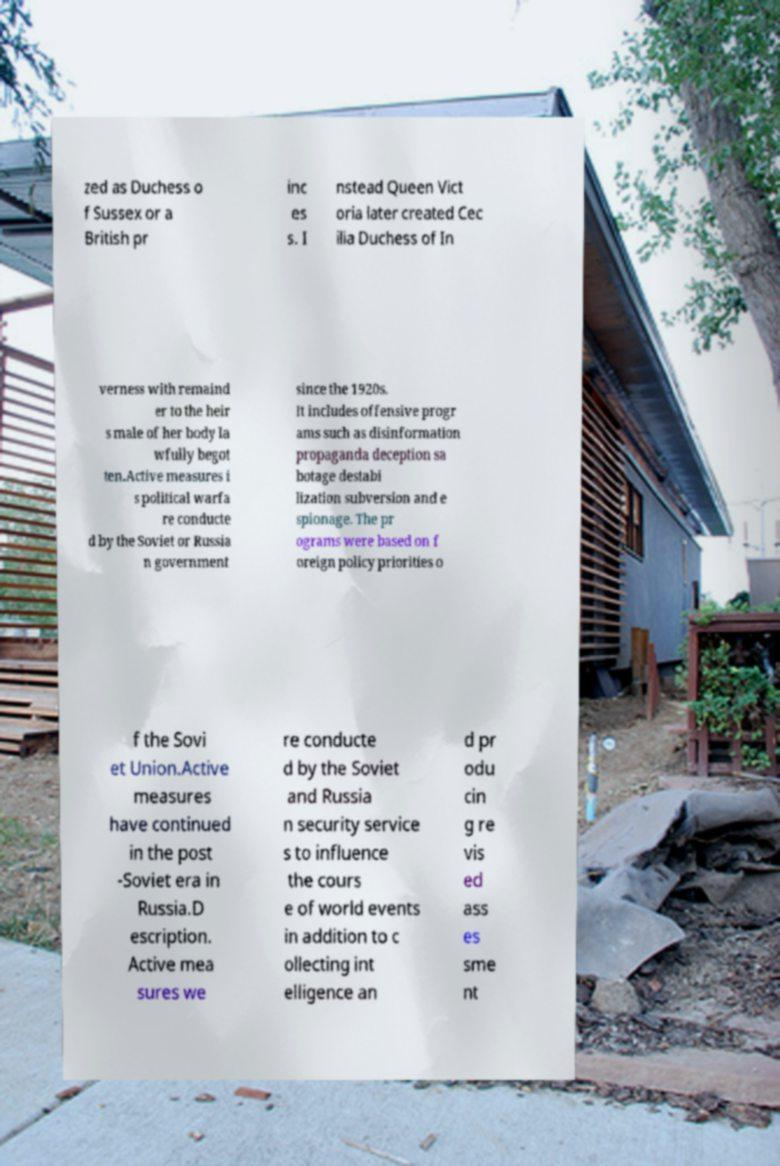Can you read and provide the text displayed in the image?This photo seems to have some interesting text. Can you extract and type it out for me? zed as Duchess o f Sussex or a British pr inc es s. I nstead Queen Vict oria later created Cec ilia Duchess of In verness with remaind er to the heir s male of her body la wfully begot ten.Active measures i s political warfa re conducte d by the Soviet or Russia n government since the 1920s. It includes offensive progr ams such as disinformation propaganda deception sa botage destabi lization subversion and e spionage. The pr ograms were based on f oreign policy priorities o f the Sovi et Union.Active measures have continued in the post -Soviet era in Russia.D escription. Active mea sures we re conducte d by the Soviet and Russia n security service s to influence the cours e of world events in addition to c ollecting int elligence an d pr odu cin g re vis ed ass es sme nt 